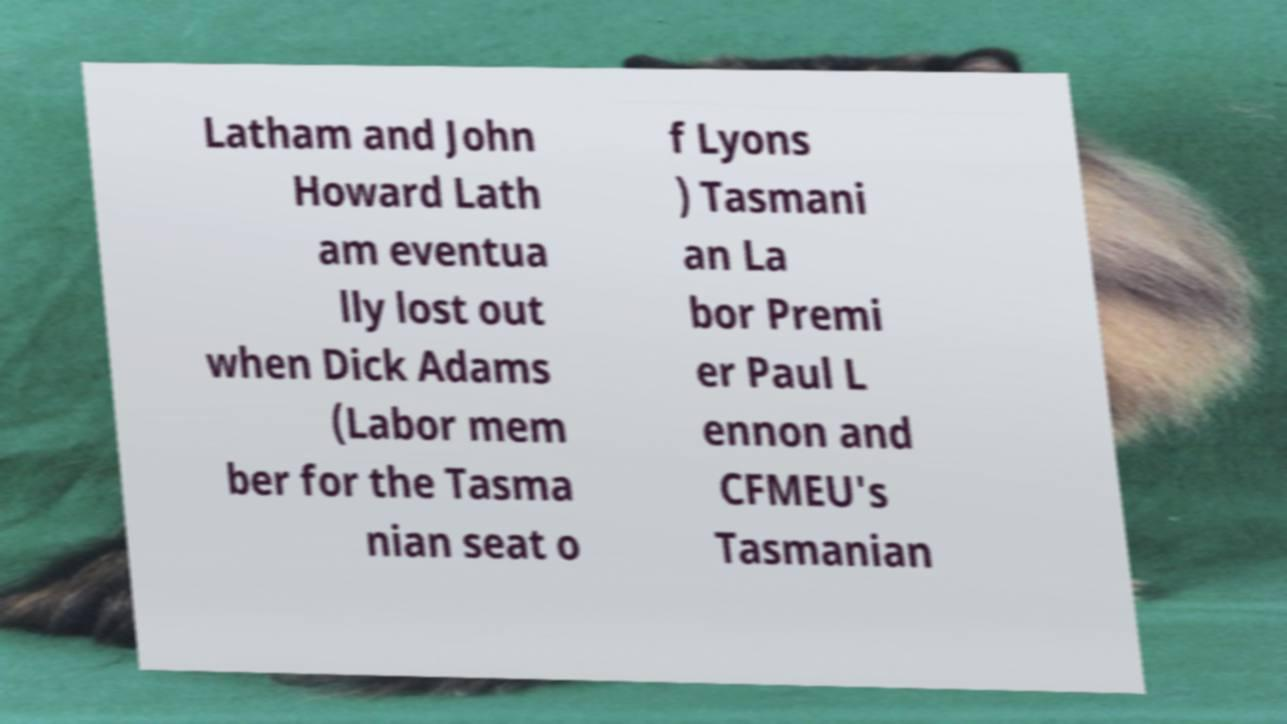Please identify and transcribe the text found in this image. Latham and John Howard Lath am eventua lly lost out when Dick Adams (Labor mem ber for the Tasma nian seat o f Lyons ) Tasmani an La bor Premi er Paul L ennon and CFMEU's Tasmanian 